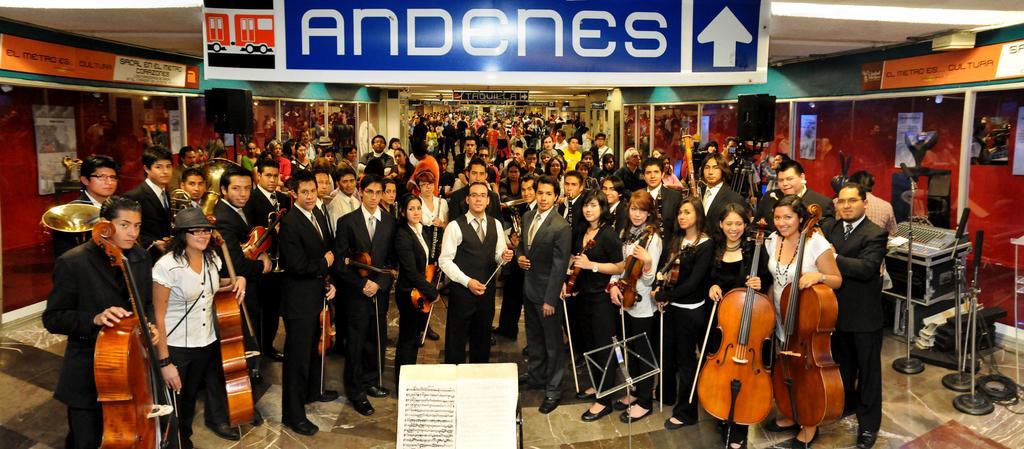Can you describe this image briefly? In the picture we can see a huge hall in it we can see many public are standing and some people are holding musical instruments and they are in blazers, ties and shirts and to the ceiling we can see a name and ones. 